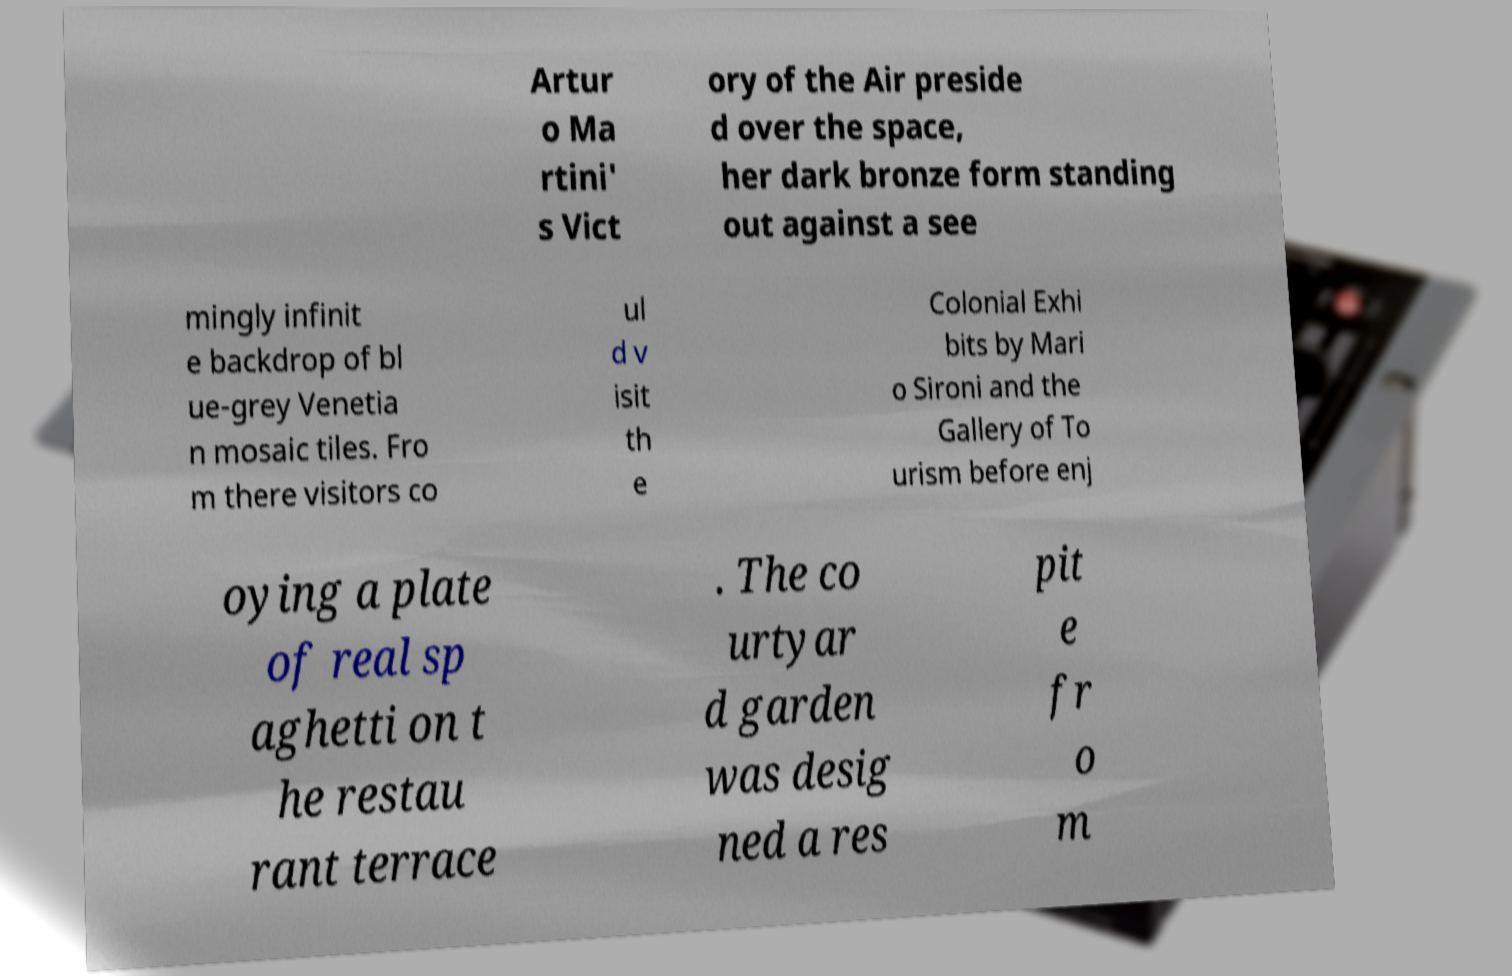Please identify and transcribe the text found in this image. Artur o Ma rtini' s Vict ory of the Air preside d over the space, her dark bronze form standing out against a see mingly infinit e backdrop of bl ue-grey Venetia n mosaic tiles. Fro m there visitors co ul d v isit th e Colonial Exhi bits by Mari o Sironi and the Gallery of To urism before enj oying a plate of real sp aghetti on t he restau rant terrace . The co urtyar d garden was desig ned a res pit e fr o m 